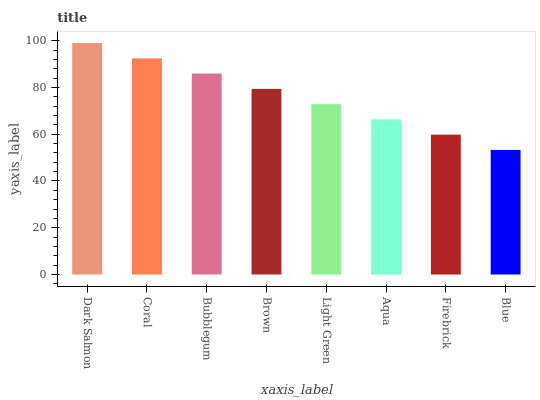Is Blue the minimum?
Answer yes or no. Yes. Is Dark Salmon the maximum?
Answer yes or no. Yes. Is Coral the minimum?
Answer yes or no. No. Is Coral the maximum?
Answer yes or no. No. Is Dark Salmon greater than Coral?
Answer yes or no. Yes. Is Coral less than Dark Salmon?
Answer yes or no. Yes. Is Coral greater than Dark Salmon?
Answer yes or no. No. Is Dark Salmon less than Coral?
Answer yes or no. No. Is Brown the high median?
Answer yes or no. Yes. Is Light Green the low median?
Answer yes or no. Yes. Is Coral the high median?
Answer yes or no. No. Is Coral the low median?
Answer yes or no. No. 